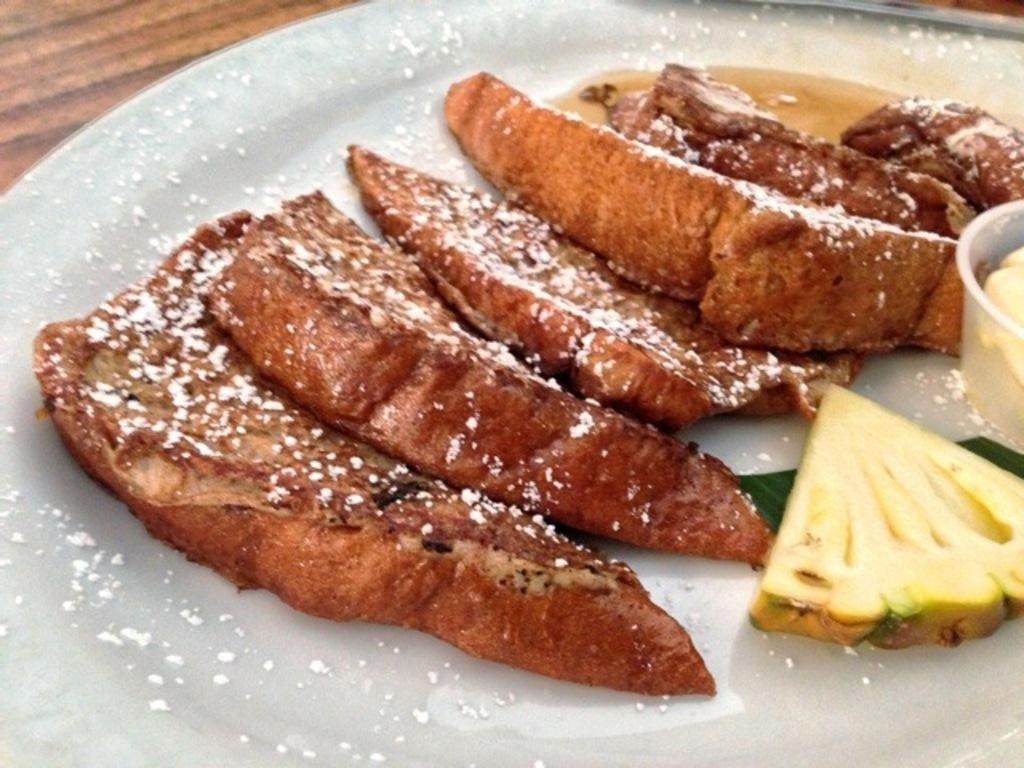What is on the plate that is visible in the image? There is a plate with food items in the image. Where is the plate located in the image? The plate is placed on a table. Can you describe the setting where the plate is located? The image is likely taken in a room. What color is the pail that is being used to draw attention in the image? There is no pail present in the image, and no object is being used to draw attention. 